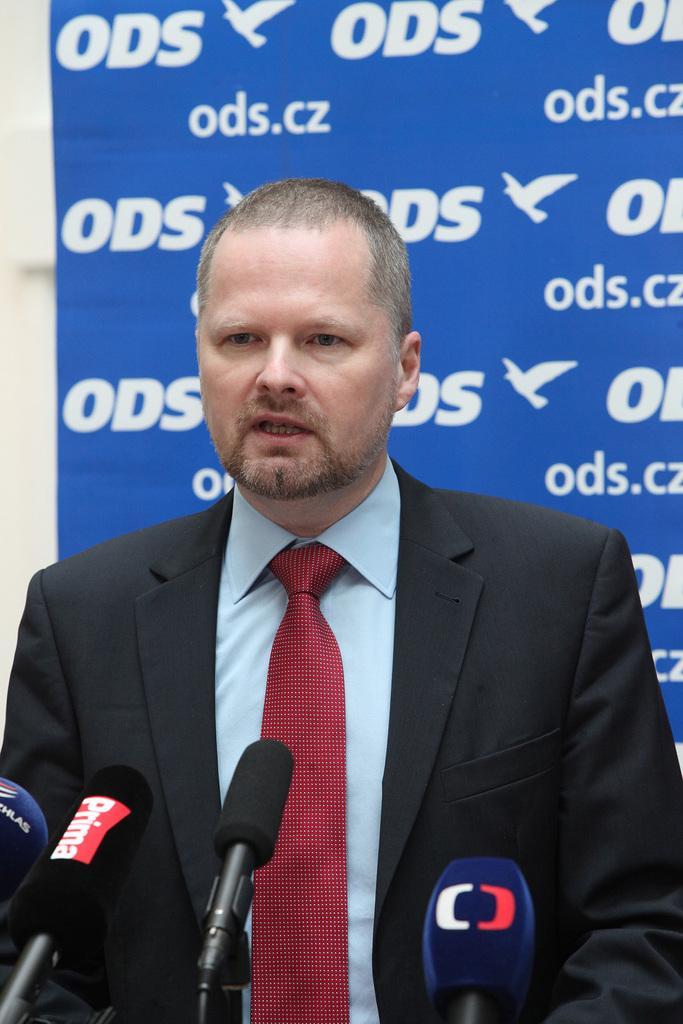How would you summarize this image in a sentence or two? This is the man standing. He wore a shirt, tie and suit. These are the mikes. In the background, I think this is a hoarding with the letters on it. 